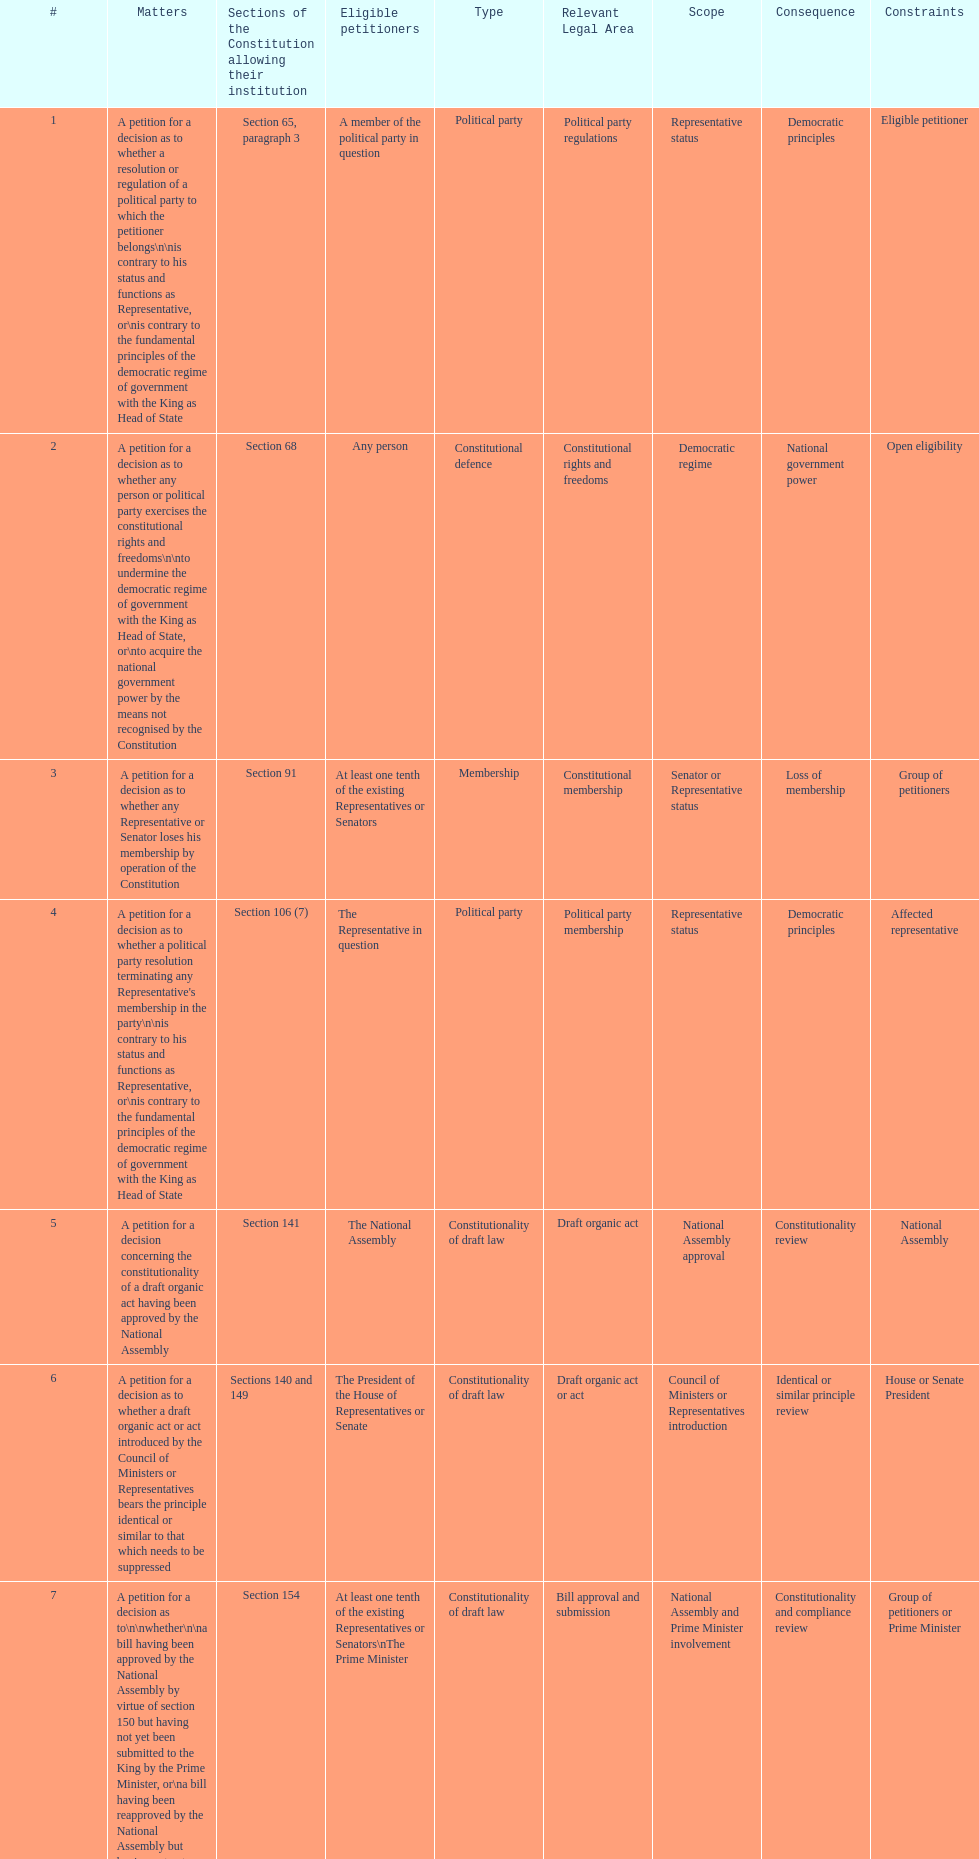How many matters have political party as their "type"? 3. 